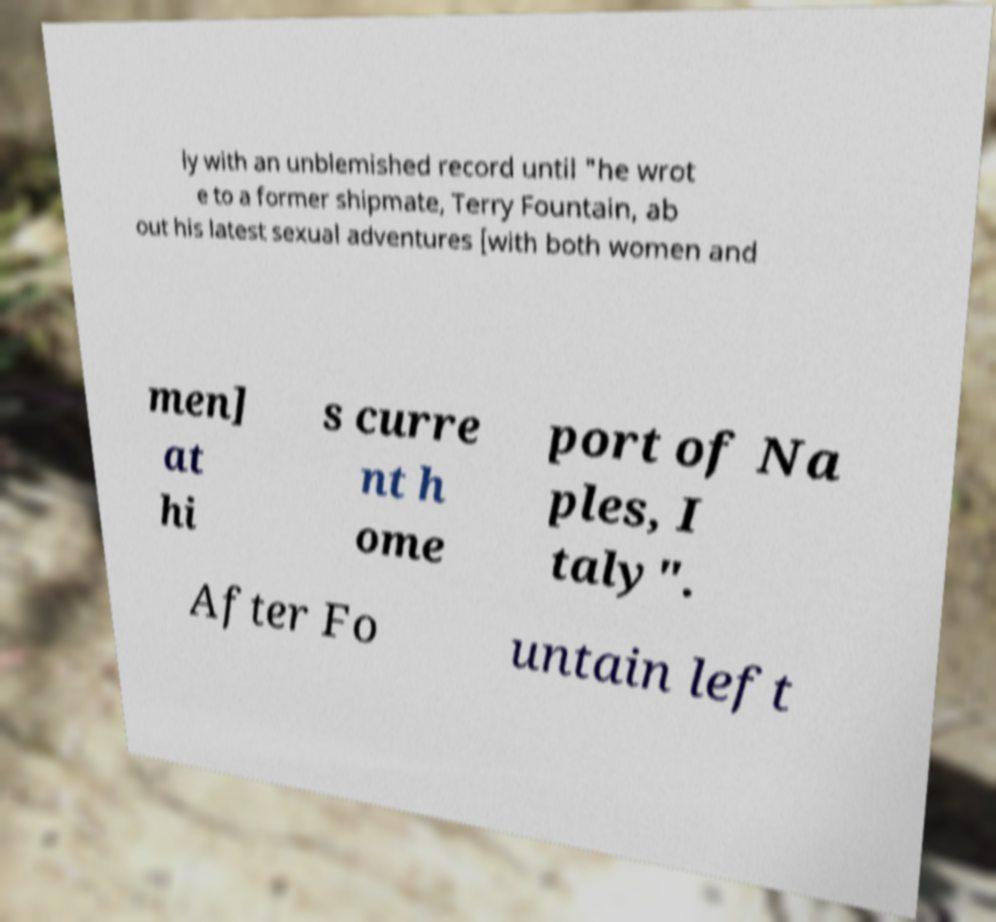Could you extract and type out the text from this image? ly with an unblemished record until "he wrot e to a former shipmate, Terry Fountain, ab out his latest sexual adventures [with both women and men] at hi s curre nt h ome port of Na ples, I taly". After Fo untain left 